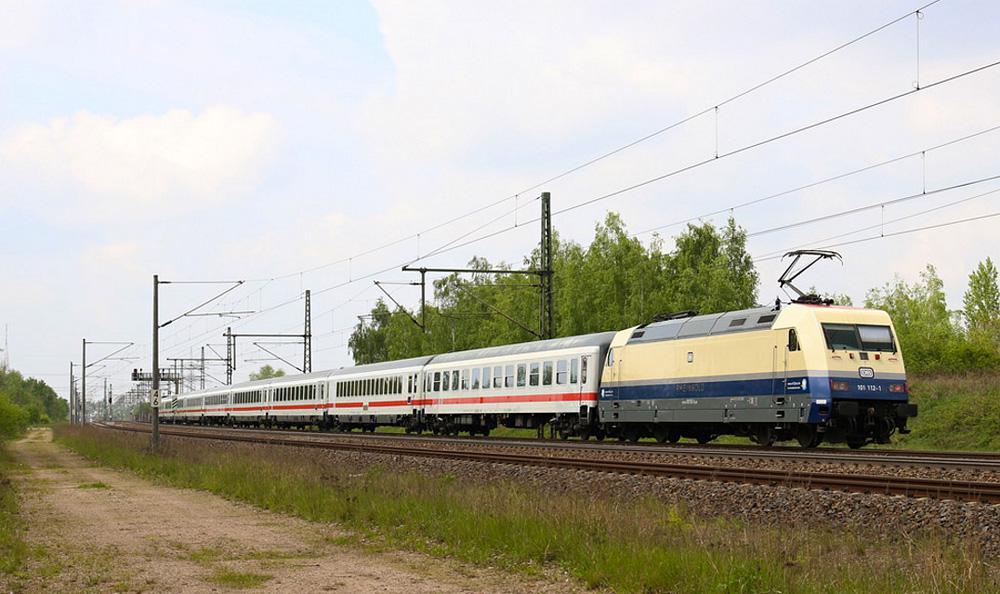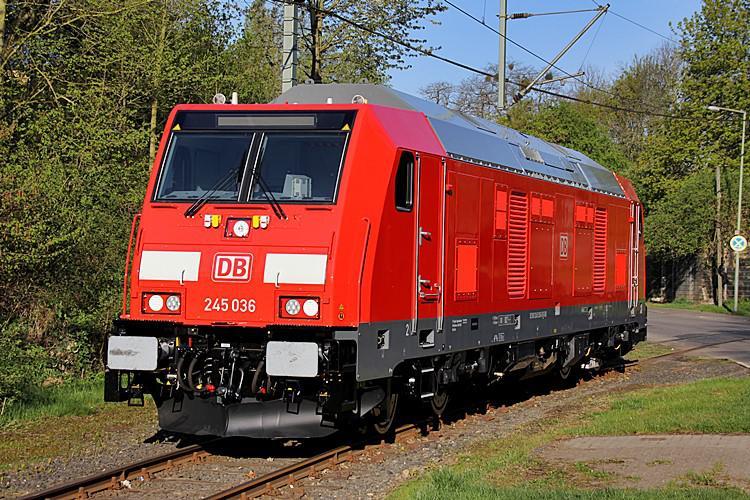The first image is the image on the left, the second image is the image on the right. Assess this claim about the two images: "on the right side a single care is heading to the left". Correct or not? Answer yes or no. Yes. The first image is the image on the left, the second image is the image on the right. For the images shown, is this caption "In the right image, the train doesn't appear to be hauling anything." true? Answer yes or no. Yes. 